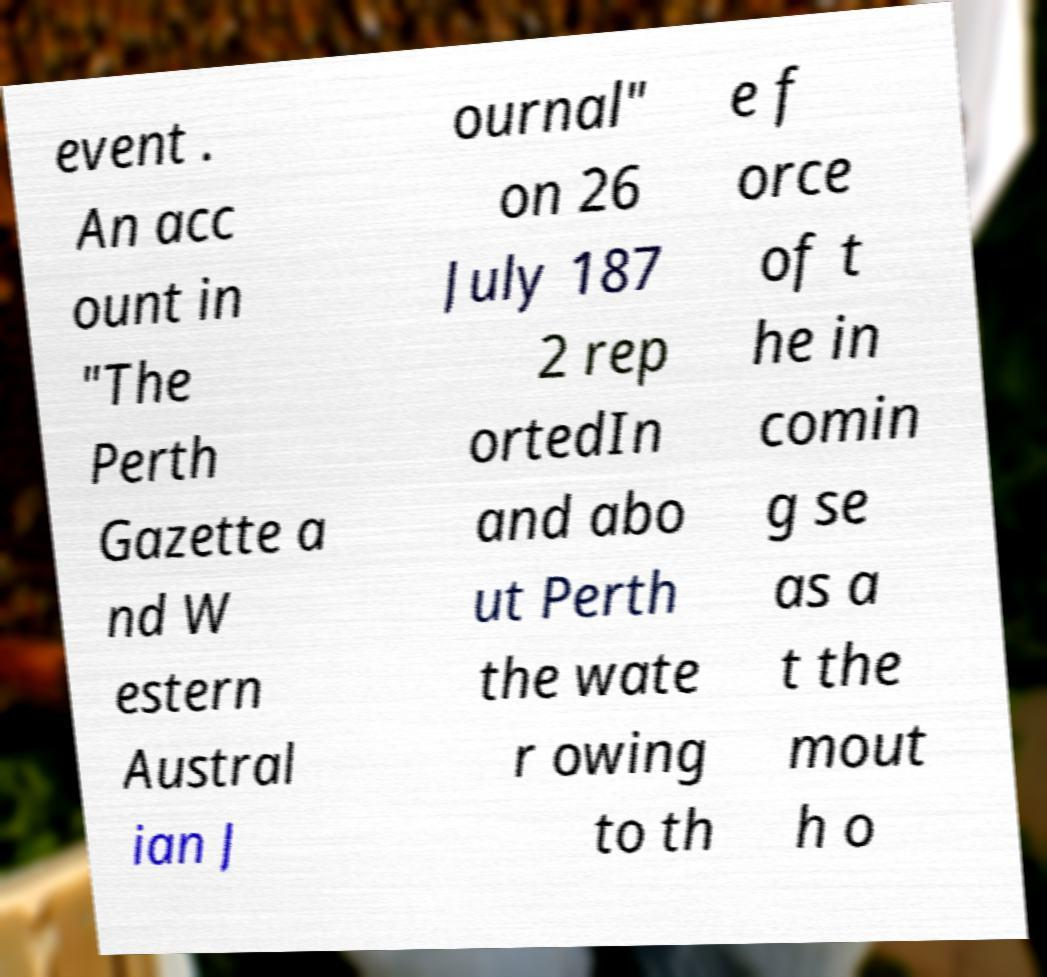I need the written content from this picture converted into text. Can you do that? event . An acc ount in "The Perth Gazette a nd W estern Austral ian J ournal" on 26 July 187 2 rep ortedIn and abo ut Perth the wate r owing to th e f orce of t he in comin g se as a t the mout h o 